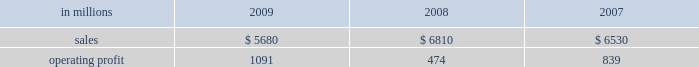Mill in the fourth quarter of 2008 .
This compares with 635000 tons of total downtime in 2008 of which 305000 tons were lack-of-order downtime .
Printing papers in millions 2009 2008 2007 .
North american printing papers net sales in 2009 were $ 2.8 billion compared with $ 3.4 billion in 2008 and $ 3.5 billion in 2007 .
Operating earnings in 2009 were $ 746 million ( $ 307 million excluding alter- native fuel mixture credits and plant closure costs ) compared with $ 405 million ( $ 435 million excluding shutdown costs for a paper machine ) in 2008 and $ 415 million in 2007 .
Sales volumes decreased sig- nificantly in 2009 compared with 2008 reflecting weak customer demand and reduced production capacity resulting from the shutdown of a paper machine at the franklin mill in december 2008 and the conversion of the bastrop mill to pulp production in june 2008 .
Average sales price realizations were lower reflecting slight declines for uncoated freesheet paper in domestic markets and significant declines in export markets .
Margins were also unfavorably affected by a higher proportion of shipments to lower-margin export markets .
Input costs , however , were favorable due to lower wood and chemical costs and sig- nificantly lower energy costs .
Freight costs were also lower .
Planned maintenance downtime costs in 2009 were comparable with 2008 .
Operating costs were favorable , reflecting cost control efforts and strong machine performance .
Lack-of-order downtime increased to 525000 tons in 2009 , including 120000 tons related to the shutdown of a paper machine at our franklin mill in the 2008 fourth quarter , from 135000 tons in 2008 .
Operating earnings in 2009 included $ 671 million of alternative fuel mixture cred- its , $ 223 million of costs associated with the shutdown of our franklin mill and $ 9 million of other shutdown costs , while operating earnings in 2008 included $ 30 million of costs for the shutdown of a paper machine at our franklin mill .
Looking ahead to 2010 , first-quarter sales volumes are expected to increase slightly from fourth-quarter 2009 levels .
Average sales price realizations should be higher , reflecting the full-quarter impact of sales price increases announced in the fourth quarter for converting and envelope grades of uncoated free- sheet paper and an increase in prices to export markets .
However , input costs for wood , energy and chemicals are expected to continue to increase .
Planned maintenance downtime costs should be lower and operating costs should be favorable .
Brazil ian papers net sales for 2009 of $ 960 mil- lion increased from $ 950 million in 2008 and $ 850 million in 2007 .
Operating profits for 2009 were $ 112 million compared with $ 186 million in 2008 and $ 174 million in 2007 .
Sales volumes increased in 2009 compared with 2008 for both paper and pulp reflect- ing higher export shipments .
Average sales price realizations were lower due to strong competitive pressures in the brazilian domestic market in the second half of the year , lower export prices and unfavorable foreign exchange rates .
Margins were unfavorably affected by a higher proportion of lower margin export sales .
Input costs for wood and chem- icals were favorable , but these benefits were partially offset by higher energy costs .
Planned maintenance downtime costs were lower , and operating costs were also favorable .
Earnings in 2009 were adversely impacted by unfavorable foreign exchange effects .
Entering 2010 , sales volumes are expected to be seasonally lower compared with the fourth quarter of 2009 .
Profit margins are expected to be slightly higher reflecting a more favorable geographic sales mix and improving sales price realizations in export markets , partially offset by higher planned main- tenance outage costs .
European papers net sales in 2009 were $ 1.3 bil- lion compared with $ 1.7 billion in 2008 and $ 1.5 bil- lion in 2007 .
Operating profits in 2009 of $ 92 million ( $ 115 million excluding expenses associated with the closure of the inverurie mill ) compared with $ 39 mil- lion ( $ 146 million excluding a charge to reduce the carrying value of the fixed assets at the inverurie , scotland mill to their estimated realizable value ) in 2008 and $ 171 million in 2007 .
Sales volumes in 2009 were lower than in 2008 primarily due to reduced sales of uncoated freesheet paper following the closure of the inverurie mill in 2009 .
Average sales price realizations decreased significantly in 2009 across most of western europe , but margins increased in poland and russia reflecting the effect of local currency devaluations .
Input costs were favorable as lower wood costs , particularly in russia , were only partially offset by higher energy costs in poland and higher chemical costs .
Planned main- tenance downtime costs were higher in 2009 than in 2008 , while manufacturing operating costs were lower .
Operating profits in 2009 also reflect favorable foreign exchange impacts .
Looking ahead to 2010 , sales volumes are expected to decline from strong 2009 fourth-quarter levels despite solid customer demand .
Average sales price realizations are expected to increase over the quar- ter , primarily in eastern europe , as price increases .
North american printing papers net sales where what percent of total printing paper sales in 2009? 
Computations: ((2.8 * 1000) / 5680)
Answer: 0.49296. 